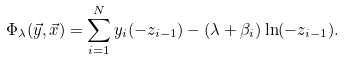<formula> <loc_0><loc_0><loc_500><loc_500>\Phi _ { \lambda } ( \vec { y } , \vec { x } ) = \sum _ { i = 1 } ^ { N } y _ { i } ( - z _ { i - 1 } ) - ( \lambda + \beta _ { i } ) \ln ( - z _ { i - 1 } ) .</formula> 